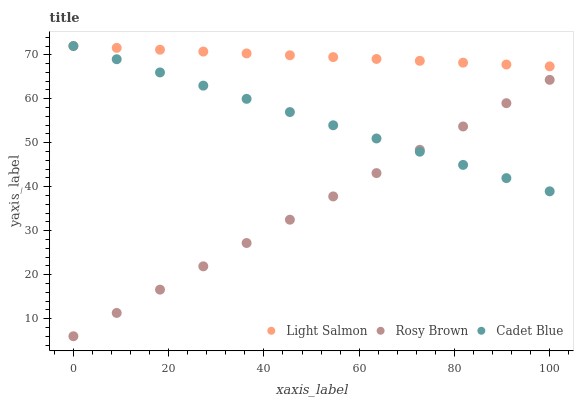Does Rosy Brown have the minimum area under the curve?
Answer yes or no. Yes. Does Light Salmon have the maximum area under the curve?
Answer yes or no. Yes. Does Light Salmon have the minimum area under the curve?
Answer yes or no. No. Does Rosy Brown have the maximum area under the curve?
Answer yes or no. No. Is Rosy Brown the smoothest?
Answer yes or no. Yes. Is Light Salmon the roughest?
Answer yes or no. Yes. Is Light Salmon the smoothest?
Answer yes or no. No. Is Rosy Brown the roughest?
Answer yes or no. No. Does Rosy Brown have the lowest value?
Answer yes or no. Yes. Does Light Salmon have the lowest value?
Answer yes or no. No. Does Light Salmon have the highest value?
Answer yes or no. Yes. Does Rosy Brown have the highest value?
Answer yes or no. No. Is Rosy Brown less than Light Salmon?
Answer yes or no. Yes. Is Light Salmon greater than Rosy Brown?
Answer yes or no. Yes. Does Light Salmon intersect Cadet Blue?
Answer yes or no. Yes. Is Light Salmon less than Cadet Blue?
Answer yes or no. No. Is Light Salmon greater than Cadet Blue?
Answer yes or no. No. Does Rosy Brown intersect Light Salmon?
Answer yes or no. No. 